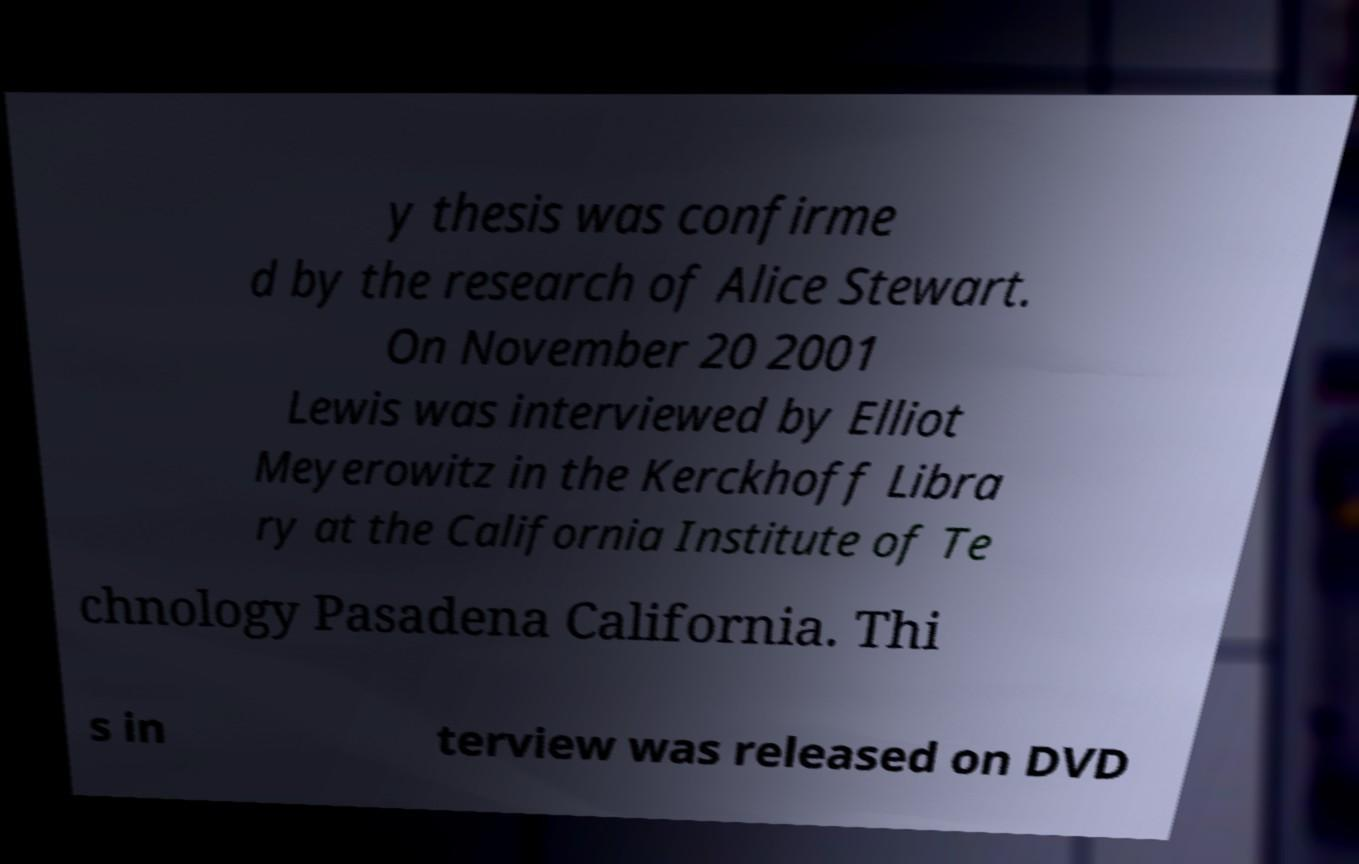Could you extract and type out the text from this image? y thesis was confirme d by the research of Alice Stewart. On November 20 2001 Lewis was interviewed by Elliot Meyerowitz in the Kerckhoff Libra ry at the California Institute of Te chnology Pasadena California. Thi s in terview was released on DVD 